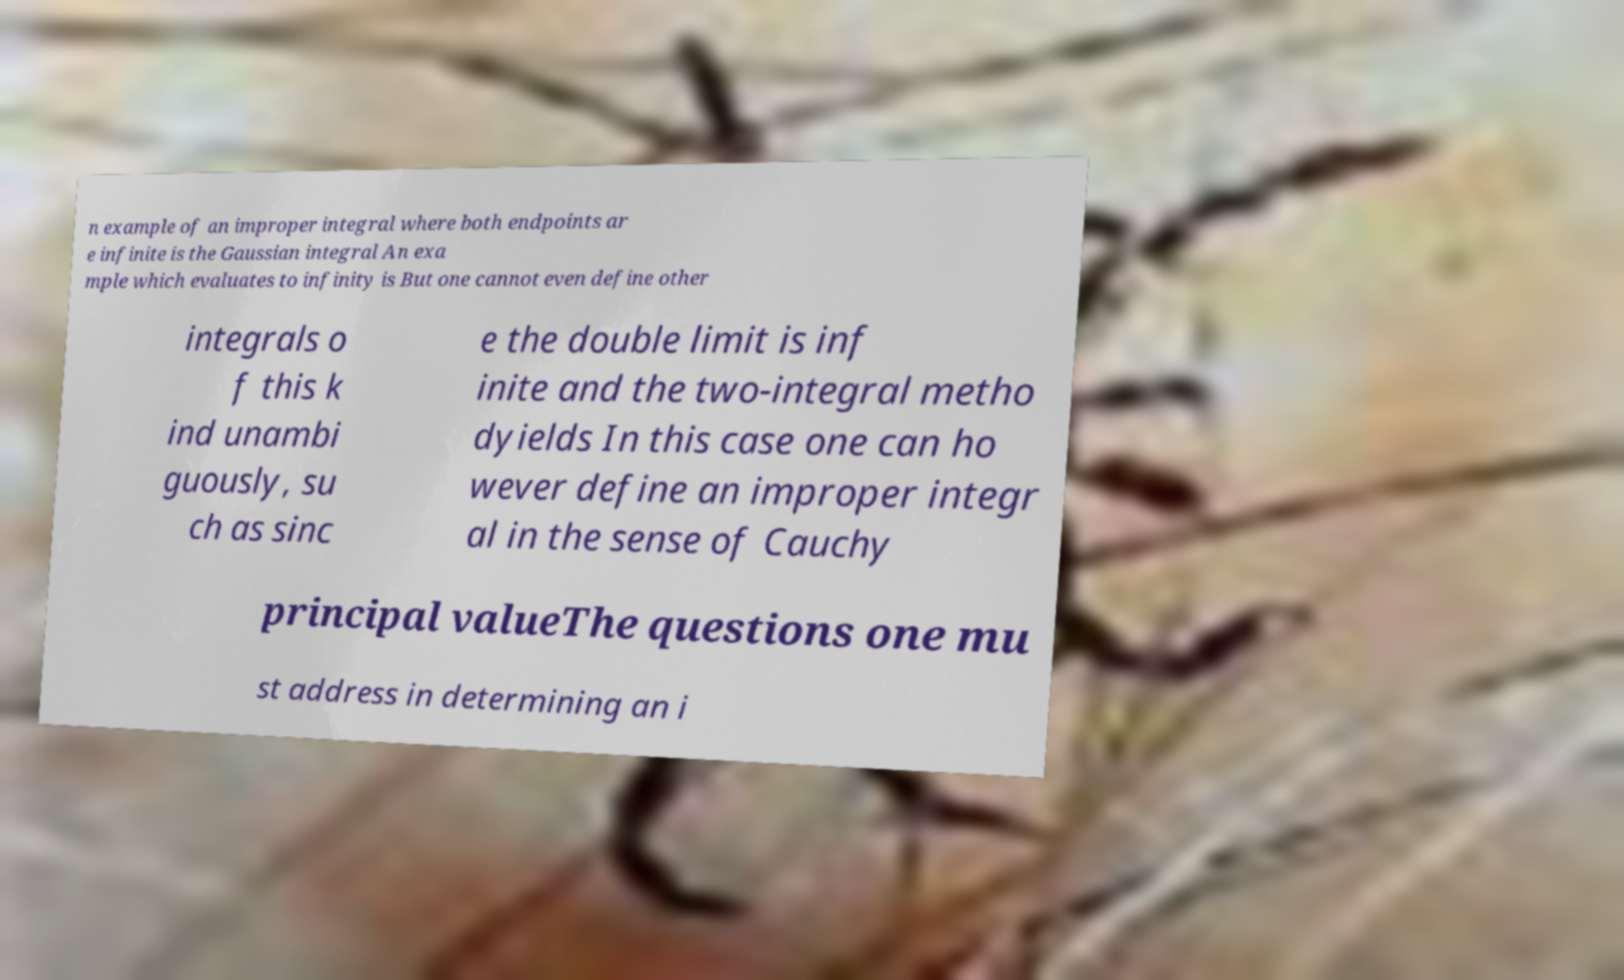Please read and relay the text visible in this image. What does it say? n example of an improper integral where both endpoints ar e infinite is the Gaussian integral An exa mple which evaluates to infinity is But one cannot even define other integrals o f this k ind unambi guously, su ch as sinc e the double limit is inf inite and the two-integral metho dyields In this case one can ho wever define an improper integr al in the sense of Cauchy principal valueThe questions one mu st address in determining an i 